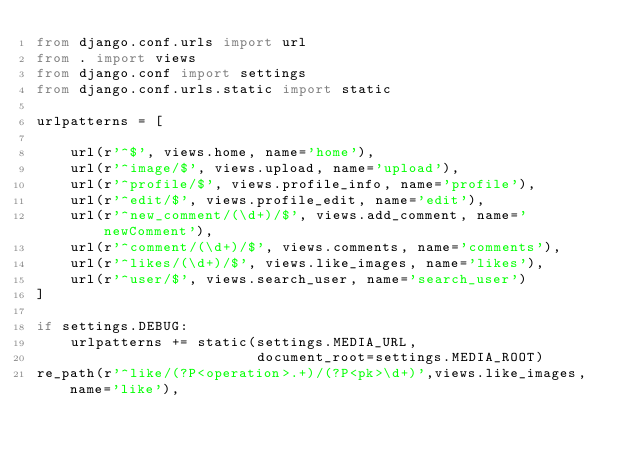<code> <loc_0><loc_0><loc_500><loc_500><_Python_>from django.conf.urls import url
from . import views
from django.conf import settings
from django.conf.urls.static import static

urlpatterns = [

    url(r'^$', views.home, name='home'),
    url(r'^image/$', views.upload, name='upload'),
    url(r'^profile/$', views.profile_info, name='profile'),
    url(r'^edit/$', views.profile_edit, name='edit'),
    url(r'^new_comment/(\d+)/$', views.add_comment, name='newComment'),
    url(r'^comment/(\d+)/$', views.comments, name='comments'),
    url(r'^likes/(\d+)/$', views.like_images, name='likes'),
    url(r'^user/$', views.search_user, name='search_user')
]

if settings.DEBUG:
    urlpatterns += static(settings.MEDIA_URL,
                          document_root=settings.MEDIA_ROOT)
re_path(r'^like/(?P<operation>.+)/(?P<pk>\d+)',views.like_images, name='like'),
</code> 